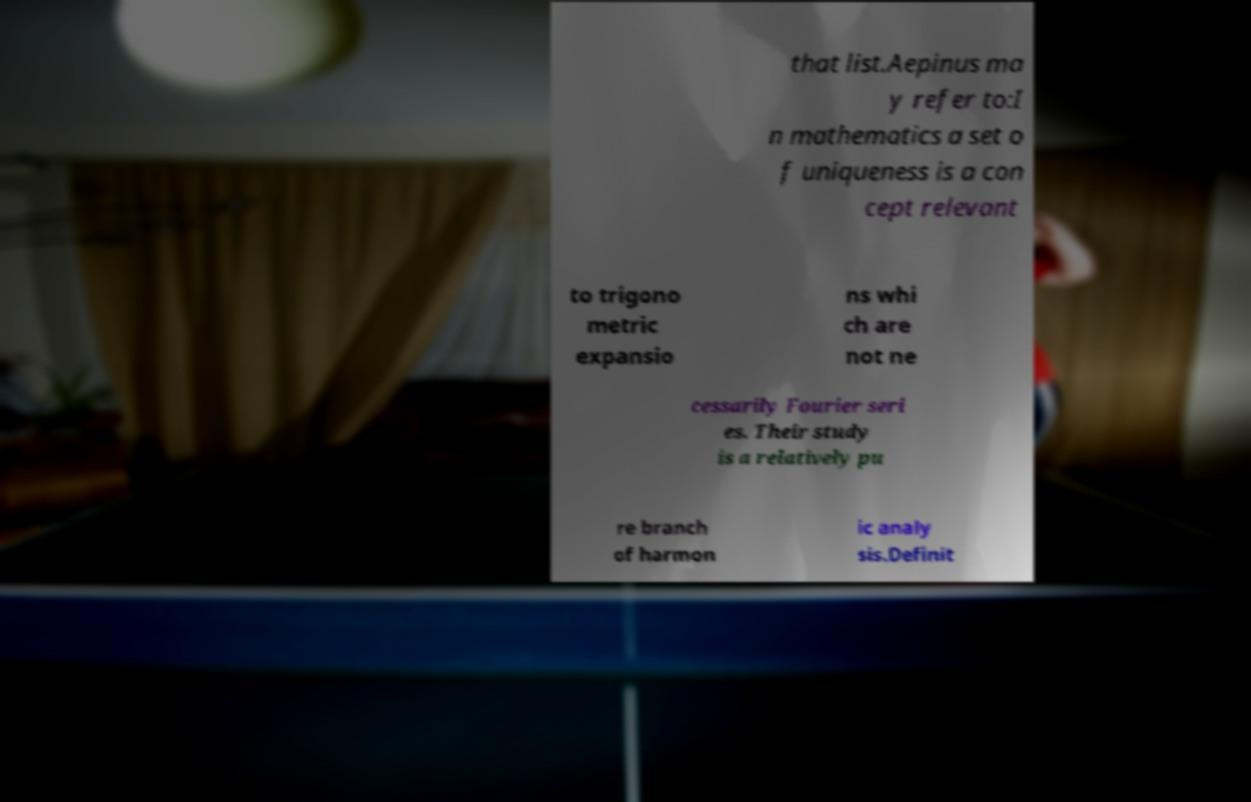Could you assist in decoding the text presented in this image and type it out clearly? that list.Aepinus ma y refer to:I n mathematics a set o f uniqueness is a con cept relevant to trigono metric expansio ns whi ch are not ne cessarily Fourier seri es. Their study is a relatively pu re branch of harmon ic analy sis.Definit 